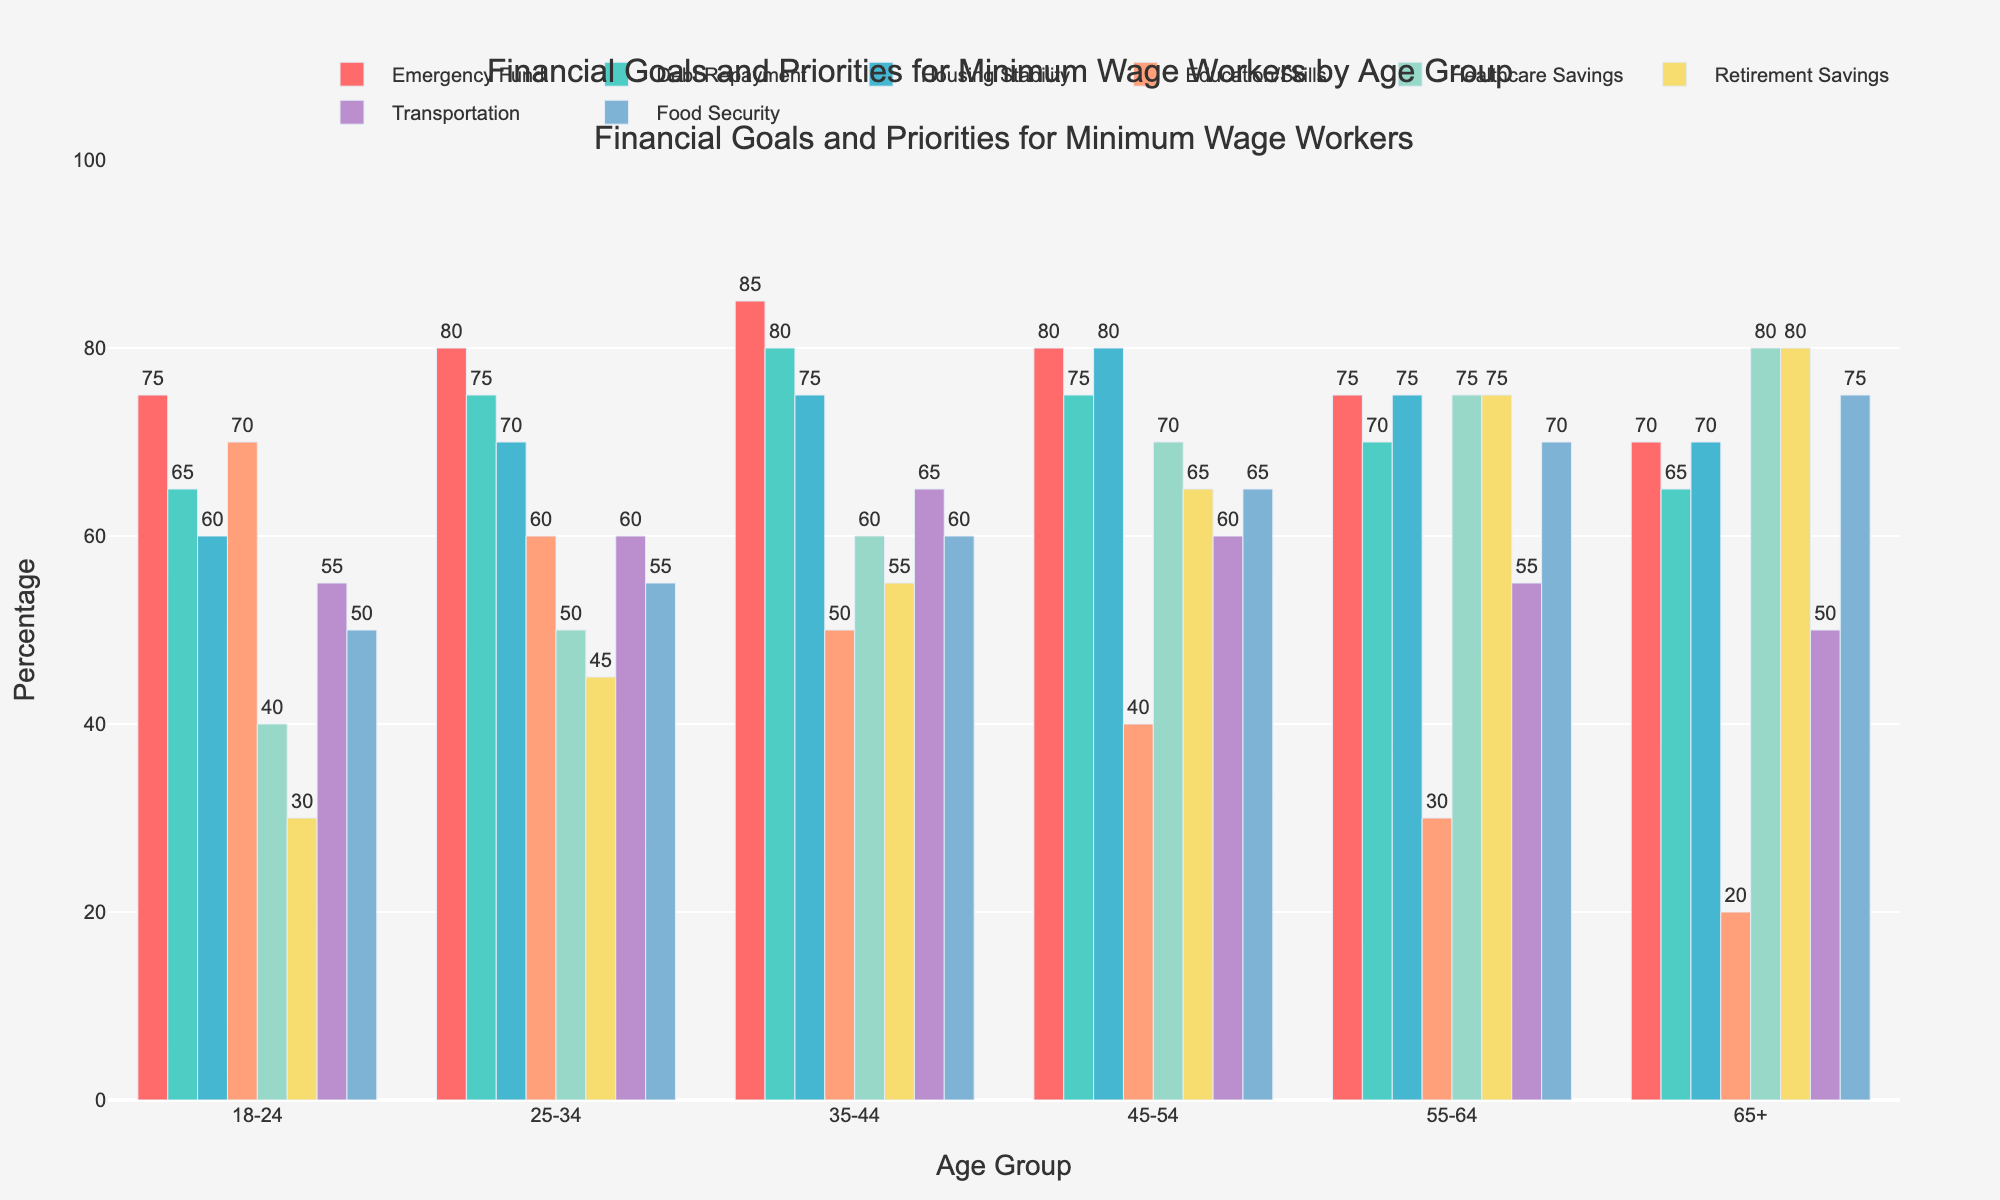Which age group has the highest priority for emergency fund savings? By looking at the height of the bars for the "Emergency Fund" category, the age group 35-44 has the highest bar reaching up to 85.
Answer: 35-44 How does the priority for debt repayment compare between the youngest (18-24) and the oldest (65+) age groups? The height of the bars for "Debt Repayment" shows that the 18-24 age group has a value of 65, while the 65+ age group has the same value of 65. Both have equal priority for debt repayment.
Answer: Equal Which financial goal consistently increases or decreases with age? Assessing the height of the bars for each financial goal category, "Retirement Savings" consistently increases with age group from 18-24 to 65+.
Answer: Retirement Savings What is the average priority given to food security across all age groups? The values for "Food Security" are 50, 55, 60, 65, 70, and 75. To find the average: (50 + 55 + 60 + 65 + 70 + 75) / 6 = 375 / 6 = 62.5
Answer: 62.5 By how much does the priority for healthcare savings increase from the 18-24 age group to the 65+ age group? The priority for "Healthcare Savings" is 40 for the 18-24 age group and 80 for the 65+ age group. The increase is 80 - 40 = 40.
Answer: 40 Which age group gives the lowest priority to education/skills, and what is the value? By examining the heights of the bars for "Education/Skills", the 65+ age group gives the lowest priority with a value of 20.
Answer: 65+, 20 In which age group is transportation equally prioritized as food security? Both the height of the bars for transportation and food security are the same for the 55-64 age group, both being 55.
Answer: 55-64 For the age group 25-34, how much higher is the priority for debt repayment compared to retirement savings? The bar heights for the 25-34 age group are 75 for debt repayment and 45 for retirement savings. The difference is 75 - 45 = 30.
Answer: 30 What is the total percentage value of all goals for the age group 35-44? Sum the values for the 35-44 age group: 85 (Emergency Fund) + 80 (Debt Repayment) + 75 (Housing Stability) + 50 (Education/Skills) + 60 (Healthcare Savings) + 55 (Retirement Savings) + 65 (Transportation) + 60 (Food Security) = 530
Answer: 530 